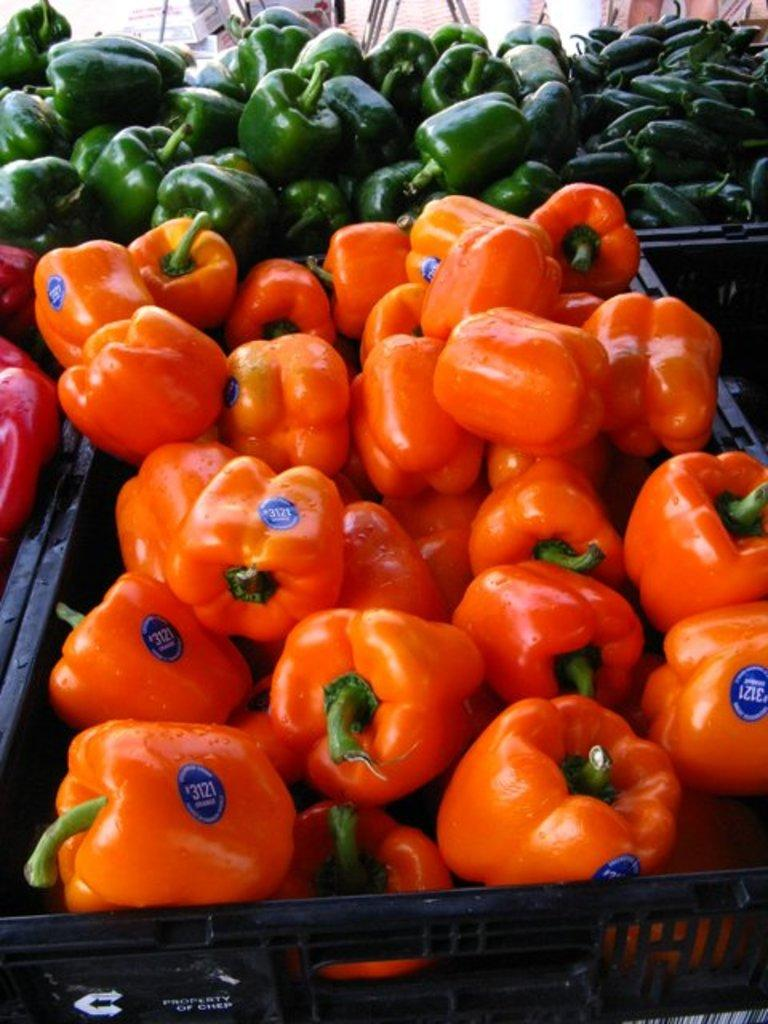What types of vegetables are present in the image? The image contains capsicums and brinjals. What are the vegetables stored in? There are baskets in the image. What other objects can be seen at the top of the image? There are boxes at the top of the image. Can you see the hand of the person who picked the vegetables in the image? There is no hand visible in the image, as it only shows the vegetables, baskets, and boxes. 